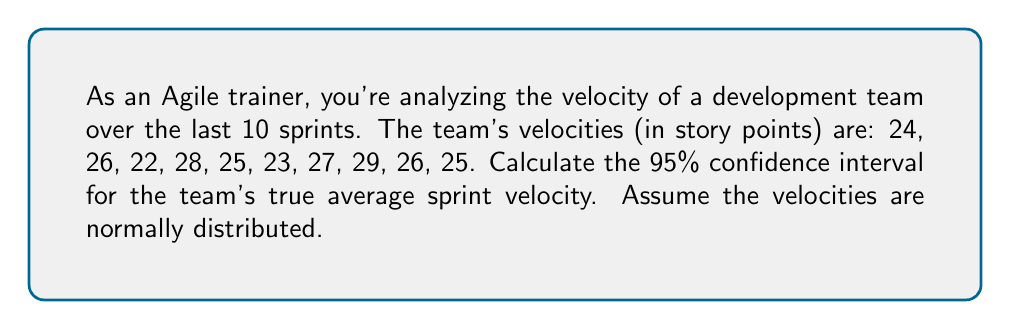What is the answer to this math problem? To calculate the confidence interval, we'll follow these steps:

1. Calculate the sample mean ($\bar{x}$):
   $$\bar{x} = \frac{24 + 26 + 22 + 28 + 25 + 23 + 27 + 29 + 26 + 25}{10} = 25.5$$

2. Calculate the sample standard deviation ($s$):
   $$s = \sqrt{\frac{\sum_{i=1}^{n} (x_i - \bar{x})^2}{n - 1}}$$
   $$s = \sqrt{\frac{(24-25.5)^2 + (26-25.5)^2 + ... + (25-25.5)^2}{9}} \approx 2.17$$

3. Determine the t-value for 95% confidence interval with 9 degrees of freedom (n-1):
   $t_{0.025,9} = 2.262$ (from t-distribution table)

4. Calculate the margin of error:
   $$\text{Margin of Error} = t_{0.025,9} \cdot \frac{s}{\sqrt{n}} = 2.262 \cdot \frac{2.17}{\sqrt{10}} \approx 1.55$$

5. Compute the confidence interval:
   $$\text{CI} = \bar{x} \pm \text{Margin of Error} = 25.5 \pm 1.55$$

Therefore, the 95% confidence interval is (23.95, 27.05).
Answer: (23.95, 27.05) story points 